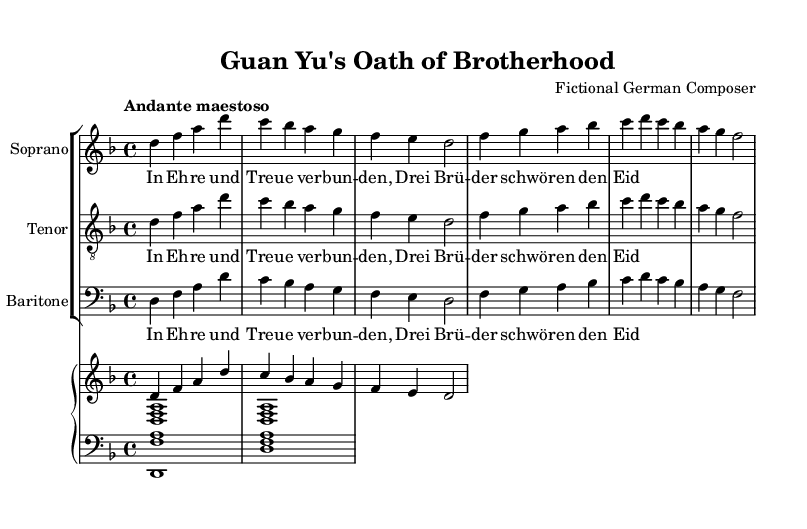What is the key signature of this music? The key signature is one flat, indicated by the presence of a B flat in the scale, which corresponds to D minor.
Answer: D minor What is the time signature of this music? The time signature is indicated at the beginning of the score, showing four beats in each measure, typical for classical pieces.
Answer: 4/4 What is the tempo marking for this piece? The tempo marking indicates the pace of the music, with "Andante maestoso" suggesting a moderate, dignified speed.
Answer: Andante maestoso How many voices are present in this opera piece? Counting the distinct vocal lines indicated in the score, there are three separate vocal parts displayed (Soprano, Tenor, Baritone).
Answer: Three What is the main theme expressed in the lyrics? Analyzing the lyrics for common threads, the central theme revolves around fidelity and brotherhood, as shown in the repeated phrase about swearing an oath.
Answer: Brotherhood Which instrument is featured in the accompaniment? The score includes a piano part that provides harmonic support across the vocal lines, a typical feature in opera compositions.
Answer: Piano What is the overall mood suggested by the tempo and lyrics? By combining the tempo marking and the lyrical content, the piece conveys a solemn and heroic mood, as it reflects on themes of loyalty and valor.
Answer: Solemn and heroic 